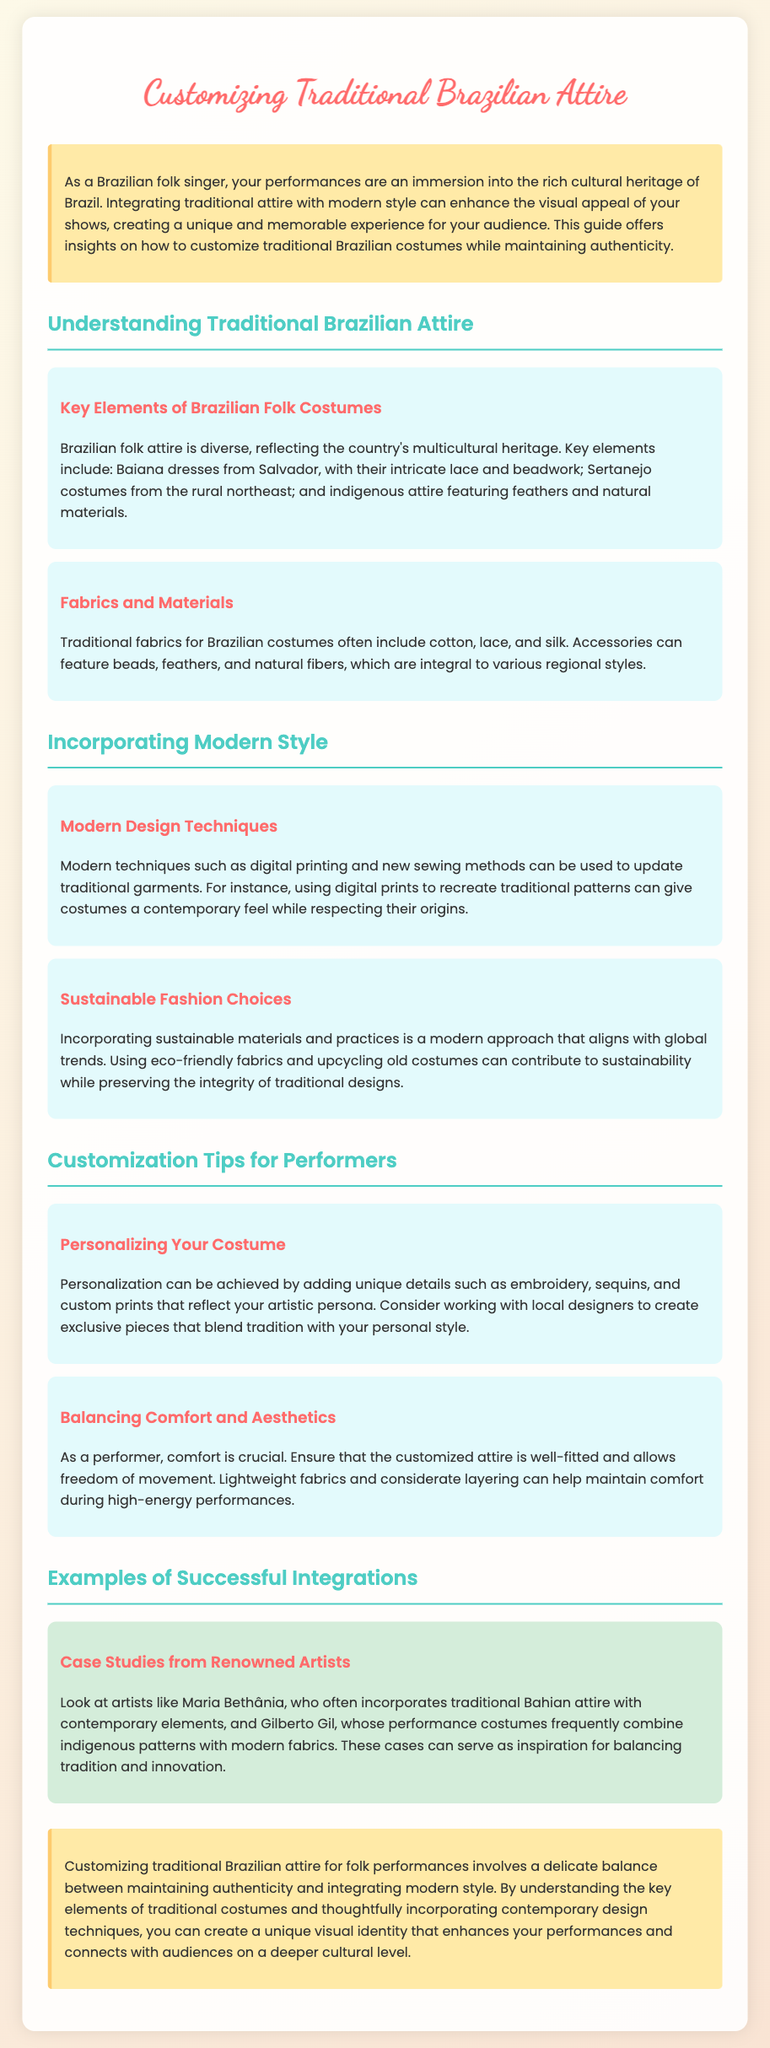what are the key elements of Brazilian folk costumes? The key elements include Baiana dresses, Sertanejo costumes, and indigenous attire.
Answer: Baiana dresses, Sertanejo costumes, and indigenous attire which materials are traditionally used in Brazilian costumes? Traditional fabrics for Brazilian costumes often include cotton, lace, and silk.
Answer: cotton, lace, and silk what techniques can modernize traditional garments? Modern techniques such as digital printing and new sewing methods can be used to update traditional garments.
Answer: digital printing and new sewing methods how can performers personalize their costumes? Personalization can be achieved by adding unique details such as embroidery, sequins, and custom prints.
Answer: embroidery, sequins, and custom prints why is comfort important for performers? Comfort is crucial because it ensures the attire is well-fitted and allows freedom of movement during performances.
Answer: freedom of movement who is an example of an artist integrating traditional attire with contemporary elements? Maria Bethânia often incorporates traditional Bahian attire with contemporary elements.
Answer: Maria Bethânia what is the main purpose of the guide? The guide offers insights on how to customize traditional Brazilian costumes while maintaining authenticity.
Answer: customize traditional Brazilian costumes while maintaining authenticity how can sustainable fashion be incorporated? Incorporating sustainable materials and practices is a modern approach that aligns with global trends.
Answer: sustainable materials and practices what should performers consider when customizing their attire? Performers should consider balancing comfort and aesthetics in their costumes.
Answer: comfort and aesthetics 